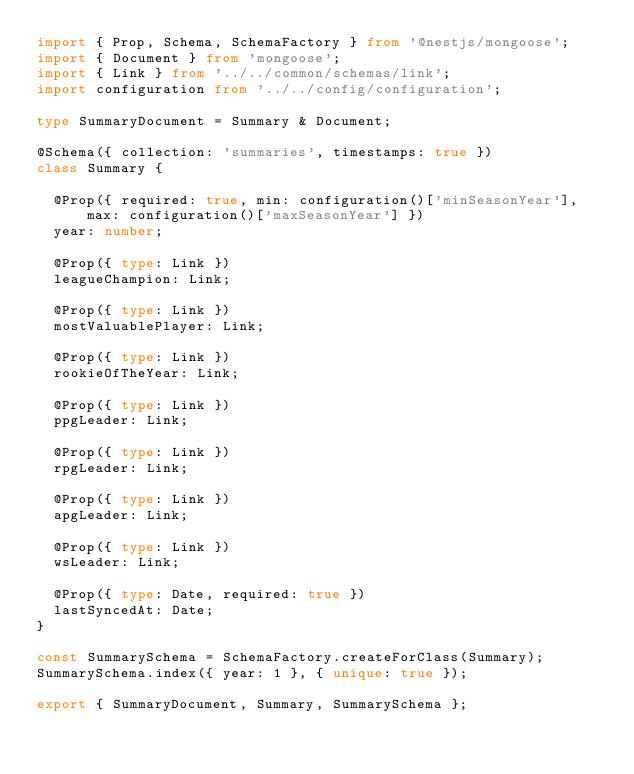Convert code to text. <code><loc_0><loc_0><loc_500><loc_500><_TypeScript_>import { Prop, Schema, SchemaFactory } from '@nestjs/mongoose';
import { Document } from 'mongoose';
import { Link } from '../../common/schemas/link';
import configuration from '../../config/configuration';

type SummaryDocument = Summary & Document;

@Schema({ collection: 'summaries', timestamps: true })
class Summary {

  @Prop({ required: true, min: configuration()['minSeasonYear'], max: configuration()['maxSeasonYear'] })
  year: number;

  @Prop({ type: Link })
  leagueChampion: Link;

  @Prop({ type: Link })
  mostValuablePlayer: Link;

  @Prop({ type: Link })
  rookieOfTheYear: Link;

  @Prop({ type: Link })
  ppgLeader: Link;

  @Prop({ type: Link })
  rpgLeader: Link;

  @Prop({ type: Link })
  apgLeader: Link;

  @Prop({ type: Link })
  wsLeader: Link;

  @Prop({ type: Date, required: true })
  lastSyncedAt: Date;
}

const SummarySchema = SchemaFactory.createForClass(Summary);
SummarySchema.index({ year: 1 }, { unique: true });

export { SummaryDocument, Summary, SummarySchema };
</code> 